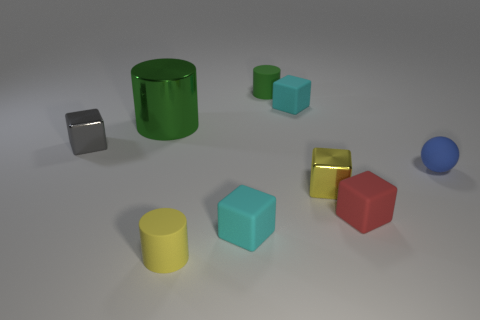Is there a big red cube made of the same material as the large green object?
Your response must be concise. No. Does the tiny cylinder that is in front of the small blue rubber object have the same color as the small sphere?
Provide a succinct answer. No. What is the size of the yellow rubber cylinder?
Your answer should be compact. Small. Is there a cyan rubber object in front of the rubber cube behind the small matte object on the right side of the red object?
Your answer should be compact. Yes. There is a small blue rubber sphere; how many tiny yellow things are on the right side of it?
Your answer should be very brief. 0. What number of other small balls have the same color as the tiny ball?
Make the answer very short. 0. How many objects are either tiny cyan rubber cubes in front of the matte ball or metal objects that are left of the big cylinder?
Provide a succinct answer. 2. Are there more tiny gray cubes than big red metal cylinders?
Ensure brevity in your answer.  Yes. There is a cylinder in front of the small yellow metallic thing; what color is it?
Keep it short and to the point. Yellow. Is the shape of the tiny blue thing the same as the small gray shiny thing?
Give a very brief answer. No. 